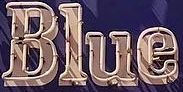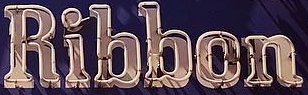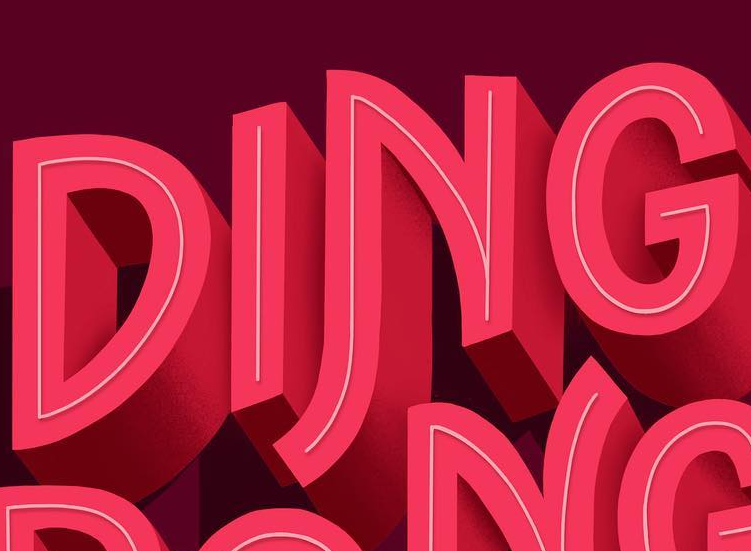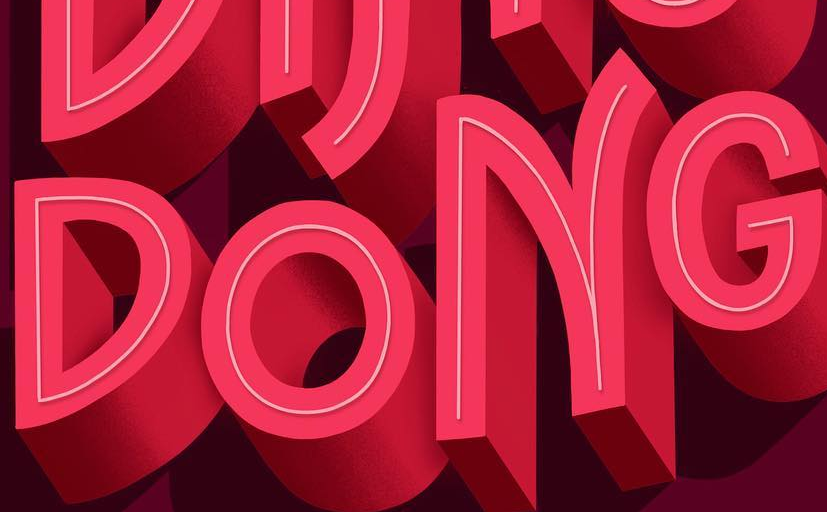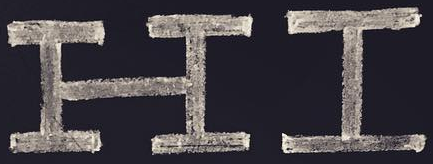Identify the words shown in these images in order, separated by a semicolon. Blue; Ribbon; DING; DONG; HI 